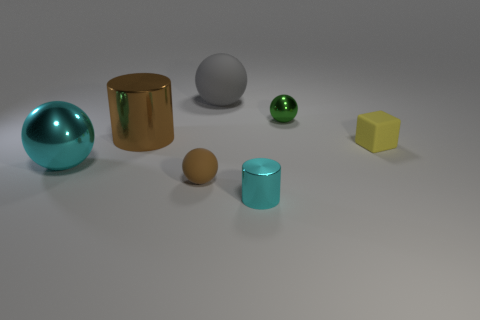Is there a big brown shiny cylinder on the right side of the large object behind the shiny cylinder on the left side of the big gray sphere?
Provide a short and direct response. No. Is there a brown sphere of the same size as the yellow rubber cube?
Offer a terse response. Yes. There is a brown object that is the same size as the gray sphere; what material is it?
Keep it short and to the point. Metal. There is a block; is it the same size as the shiny ball that is to the left of the large gray sphere?
Provide a succinct answer. No. What number of metallic objects are small spheres or large brown cylinders?
Offer a very short reply. 2. What number of other cyan shiny objects are the same shape as the small cyan object?
Provide a succinct answer. 0. There is a thing that is the same color as the big shiny ball; what is it made of?
Your answer should be very brief. Metal. Does the yellow thing right of the big cylinder have the same size as the cyan shiny object that is right of the tiny brown matte sphere?
Keep it short and to the point. Yes. There is a big metallic object that is behind the big cyan metal object; what shape is it?
Offer a terse response. Cylinder. There is a large object that is the same shape as the small cyan object; what is it made of?
Offer a terse response. Metal. 